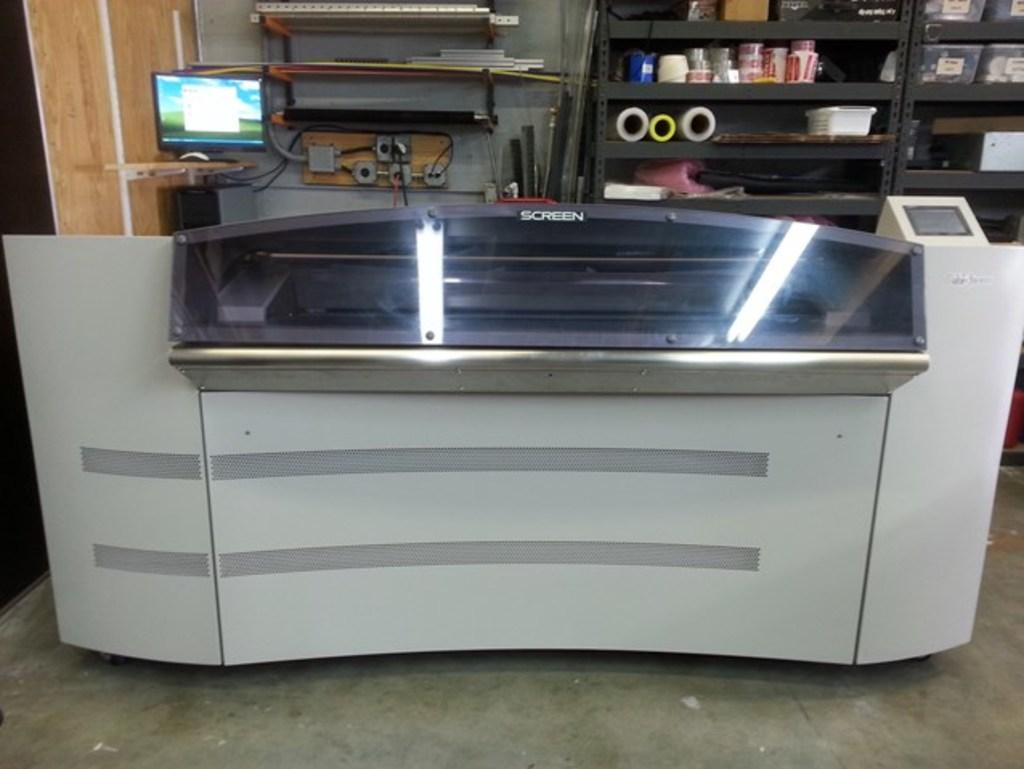What piece of furniture is present in the image? There is a desk in the image. What electronic device is on the desk? There is a computer on the desk. What can be seen connected to the computer or desk? There are wires visible in the image. What type of storage is present in the image? There are shelves with objects on them, as well as sheets, boxes, and other objects in the racks. Is there any quicksand visible in the image? No, there is no quicksand present in the image. What type of clock is hanging on the wall in the image? There is no clock visible in the image, and the image does not show a wall. 